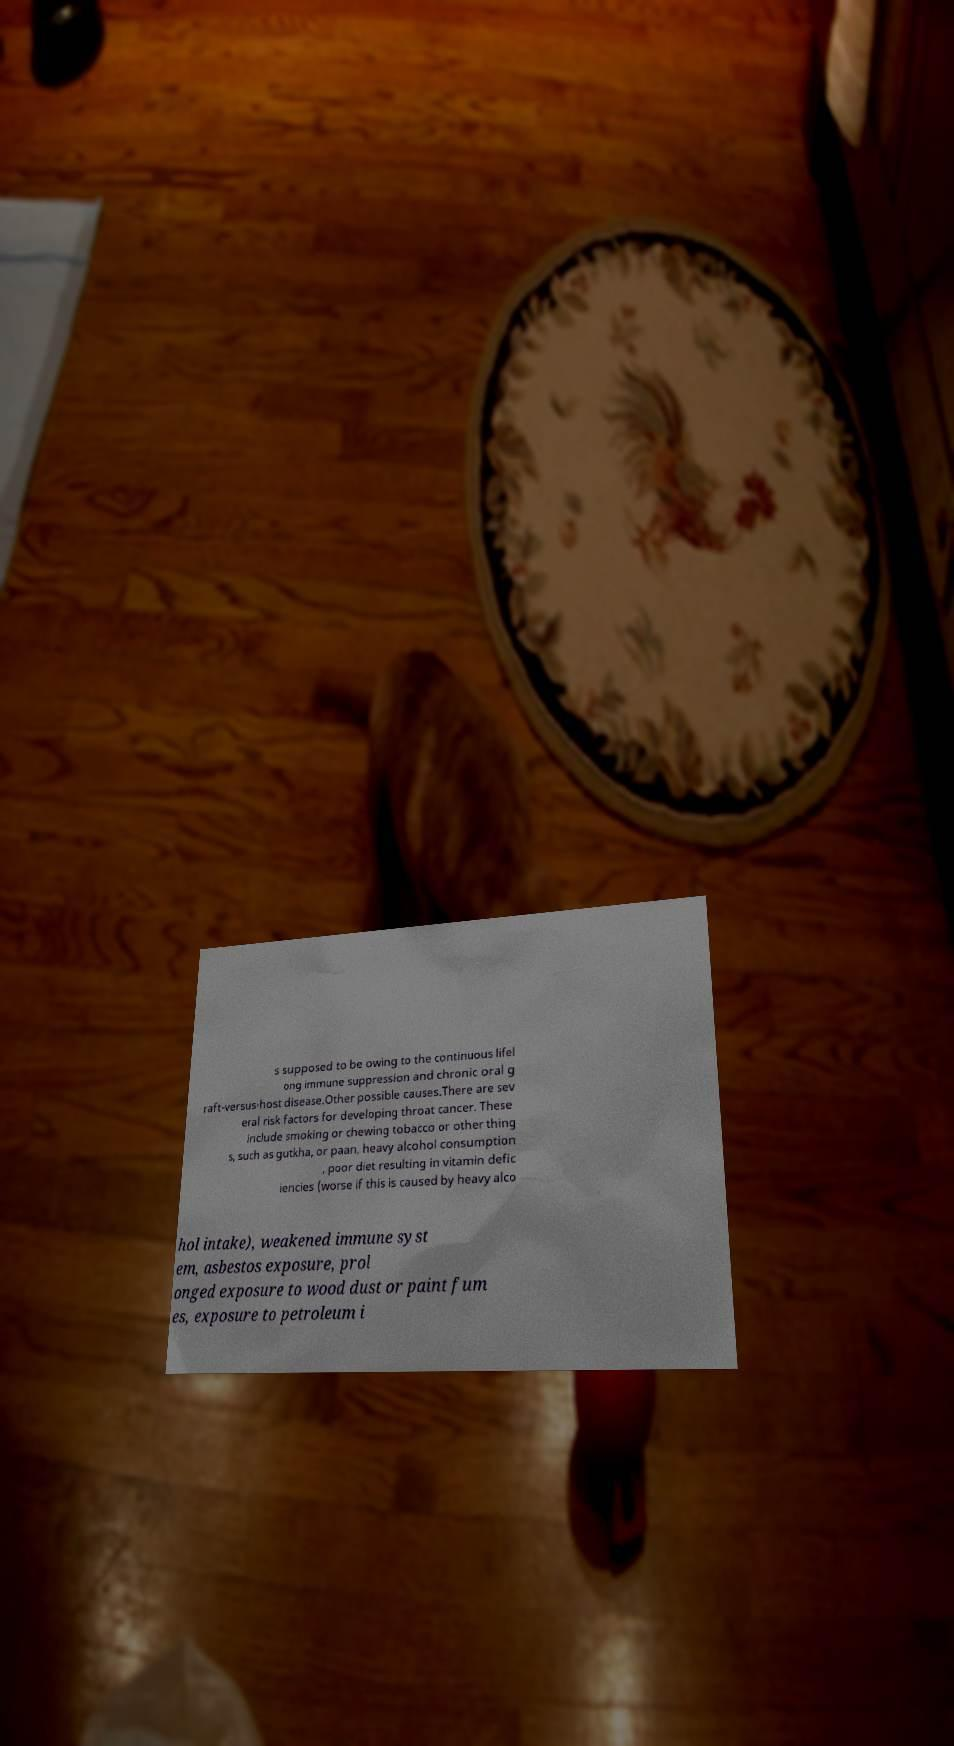Please identify and transcribe the text found in this image. s supposed to be owing to the continuous lifel ong immune suppression and chronic oral g raft-versus-host disease.Other possible causes.There are sev eral risk factors for developing throat cancer. These include smoking or chewing tobacco or other thing s, such as gutkha, or paan, heavy alcohol consumption , poor diet resulting in vitamin defic iencies (worse if this is caused by heavy alco hol intake), weakened immune syst em, asbestos exposure, prol onged exposure to wood dust or paint fum es, exposure to petroleum i 